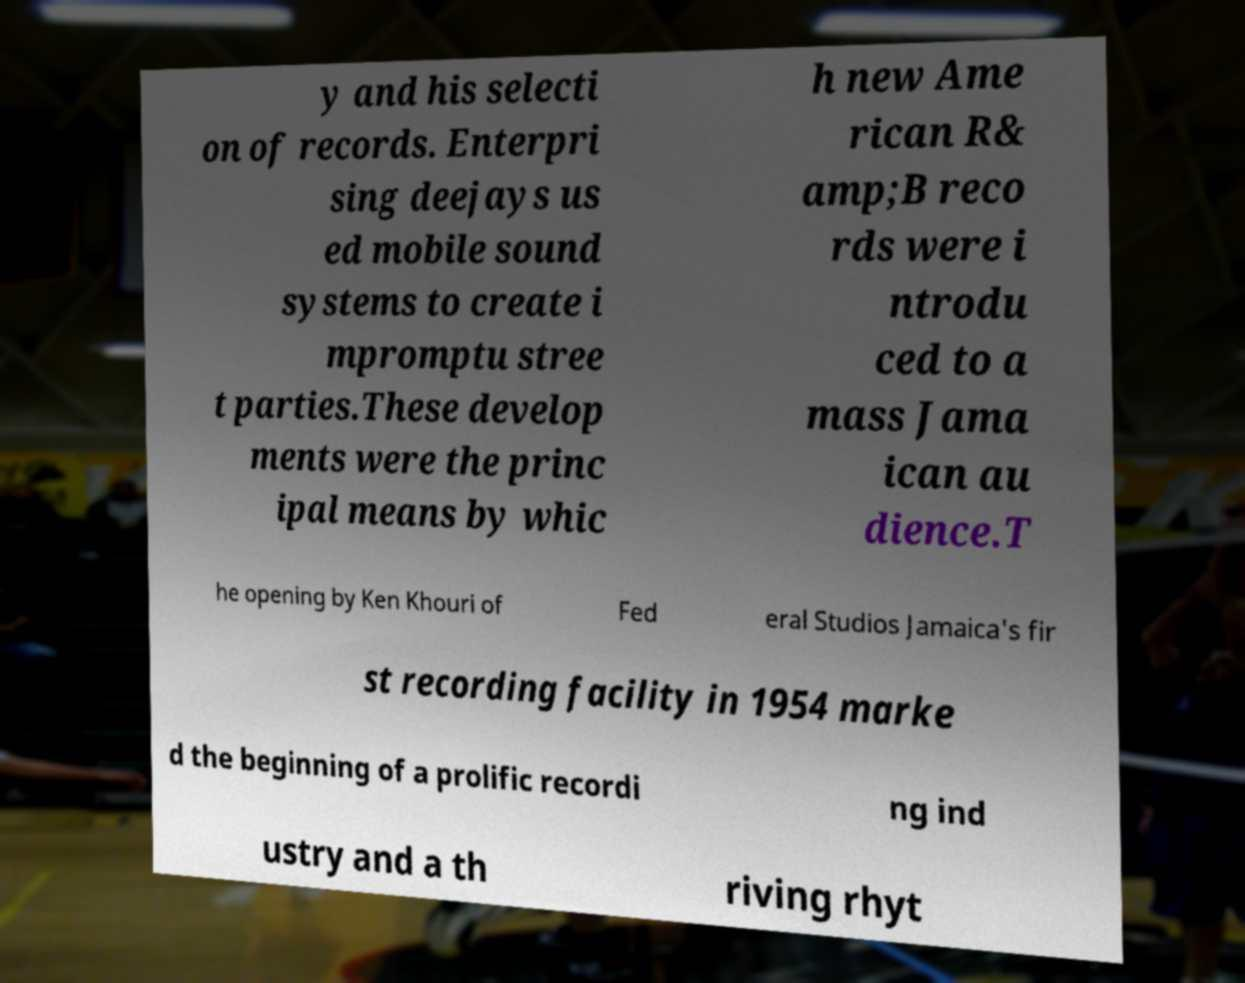Please read and relay the text visible in this image. What does it say? y and his selecti on of records. Enterpri sing deejays us ed mobile sound systems to create i mpromptu stree t parties.These develop ments were the princ ipal means by whic h new Ame rican R& amp;B reco rds were i ntrodu ced to a mass Jama ican au dience.T he opening by Ken Khouri of Fed eral Studios Jamaica's fir st recording facility in 1954 marke d the beginning of a prolific recordi ng ind ustry and a th riving rhyt 